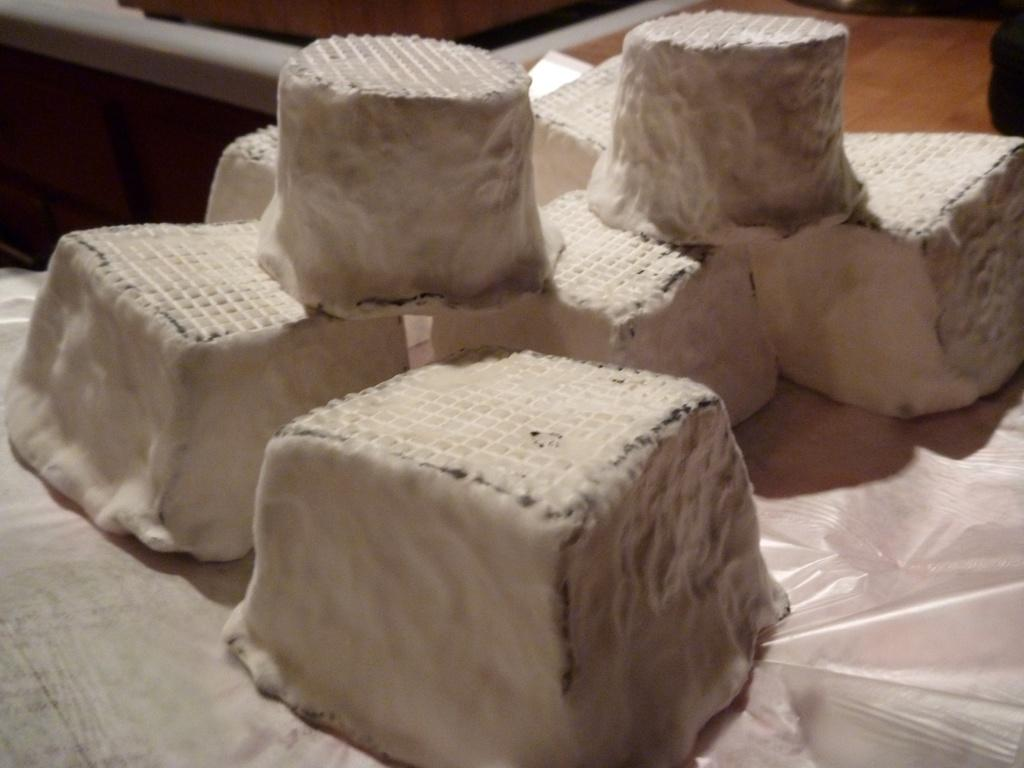What can be seen in the image? There are objects in the image. What is placed below the objects? There is a plastic sheet below the objects. What type of yarn is being used to support the objects in the image? There is no yarn present in the image; the objects are resting on a plastic sheet. 